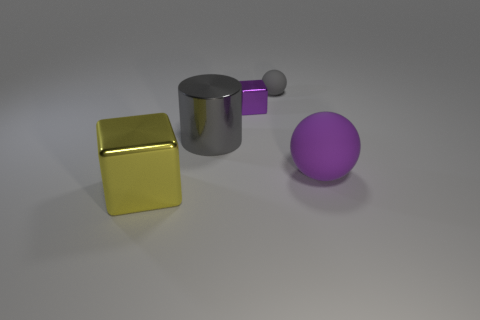Add 1 matte balls. How many objects exist? 6 Subtract all blocks. How many objects are left? 3 Subtract all gray balls. Subtract all small spheres. How many objects are left? 3 Add 5 purple matte balls. How many purple matte balls are left? 6 Add 4 tiny objects. How many tiny objects exist? 6 Subtract 0 yellow cylinders. How many objects are left? 5 